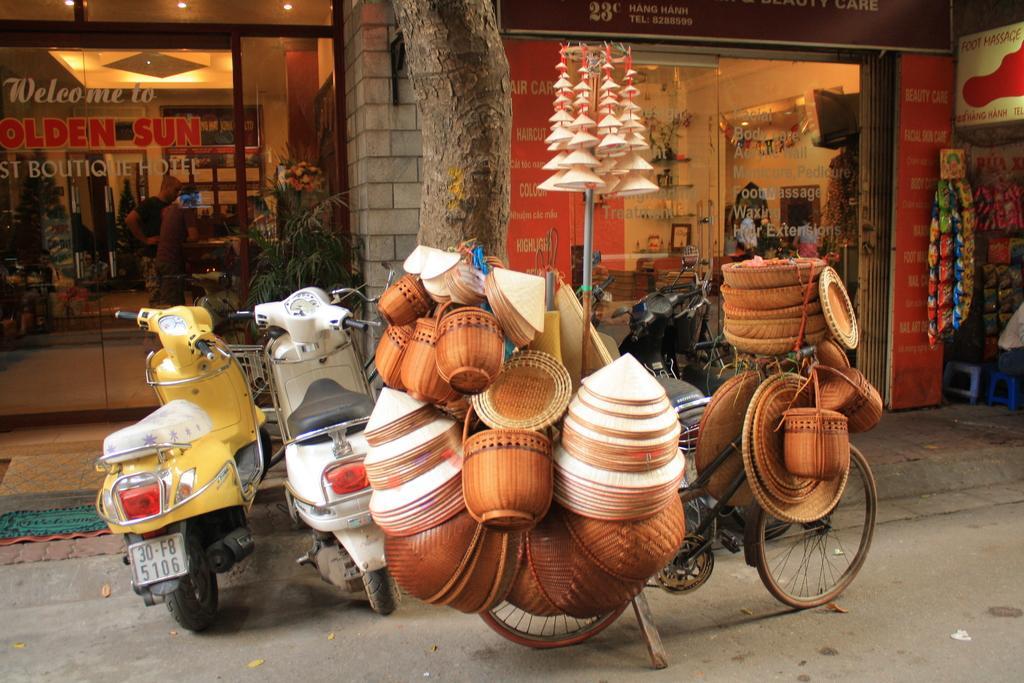How would you summarize this image in a sentence or two? In this image, we can see scooters in front of glass doors. There is a stem at the top of the image. There is a plant in the middle of the image. There is a board in the top right of the image. There are food packages on the right side of the image. There is a bicycle at the bottom of the image contains some handicrafts. There are lights in the top left of the image. 